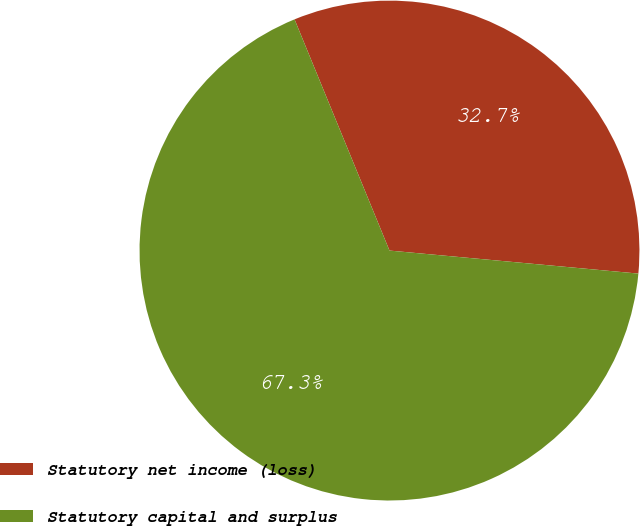Convert chart to OTSL. <chart><loc_0><loc_0><loc_500><loc_500><pie_chart><fcel>Statutory net income (loss)<fcel>Statutory capital and surplus<nl><fcel>32.67%<fcel>67.33%<nl></chart> 